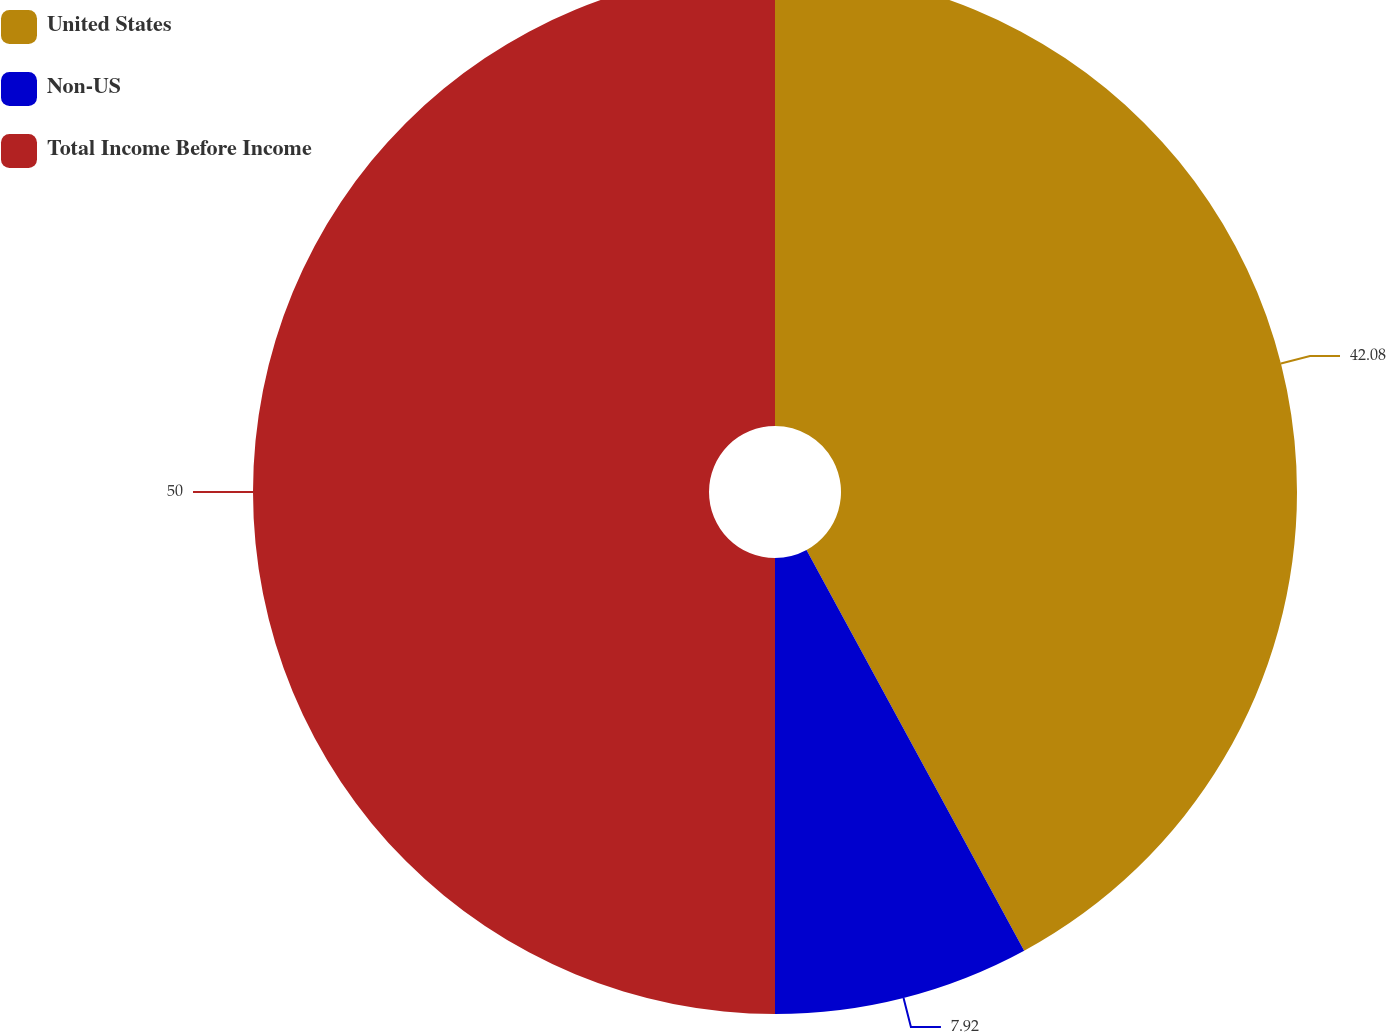<chart> <loc_0><loc_0><loc_500><loc_500><pie_chart><fcel>United States<fcel>Non-US<fcel>Total Income Before Income<nl><fcel>42.08%<fcel>7.92%<fcel>50.0%<nl></chart> 